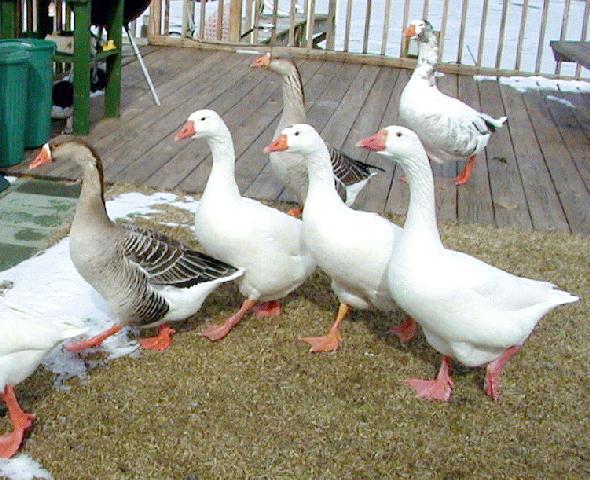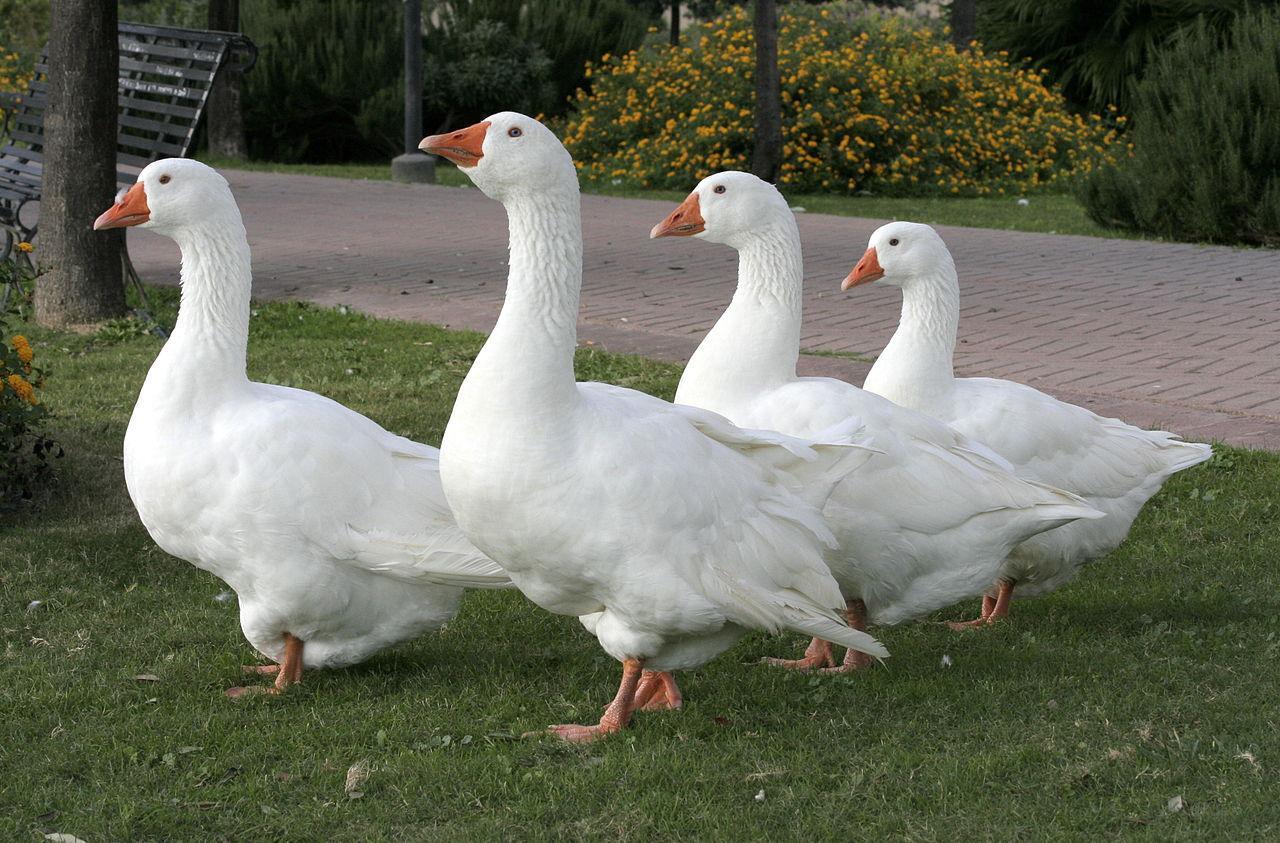The first image is the image on the left, the second image is the image on the right. Examine the images to the left and right. Is the description "There are more than ten geese in the images." accurate? Answer yes or no. Yes. The first image is the image on the left, the second image is the image on the right. Analyze the images presented: Is the assertion "There is a single goose in the right image." valid? Answer yes or no. No. 